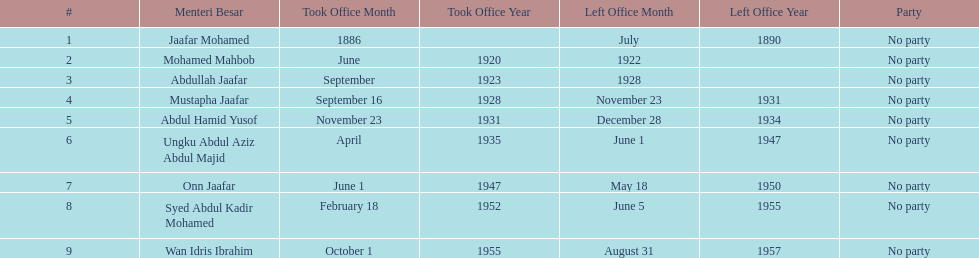Who was in office after mustapha jaafar Abdul Hamid Yusof. 